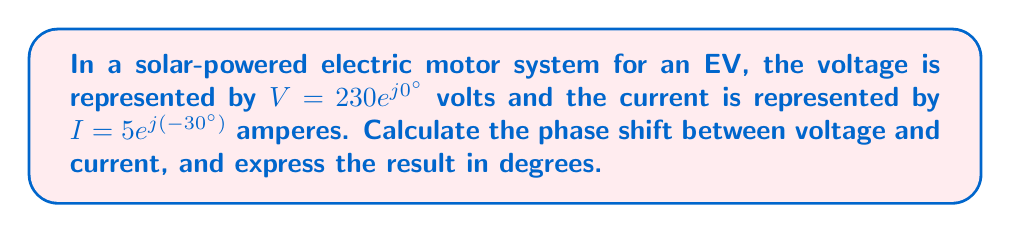Can you solve this math problem? To find the phase shift between voltage and current, we need to compare their complex representations:

1) Voltage: $V = 230e^{j0°}$
2) Current: $I = 5e^{j(-30°)}$

The phase of a complex number in the form $Ae^{j\theta}$ is given by $\theta$. 

3) Phase of voltage: $\theta_V = 0°$
4) Phase of current: $\theta_I = -30°$

5) The phase shift is the difference between these phases:
   $\Delta\theta = \theta_V - \theta_I = 0° - (-30°) = 30°$

6) A positive phase shift means that the voltage leads the current.

Therefore, the voltage leads the current by 30°.
Answer: 30° 